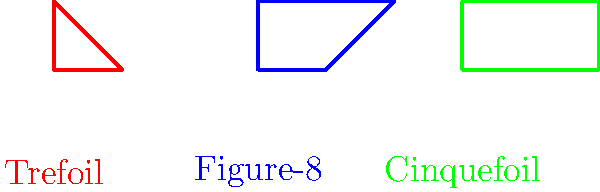Consider the three knots shown above: the Trefoil, Figure-8, and Cinquefoil knots. Which of these knots has the highest Alexander polynomial degree, and how does this relate to the knot's complexity in the grand tapestry of the universe? Let's approach this step-by-step:

1) The Alexander polynomial is a knot invariant that provides information about the complexity of a knot.

2) For the given knots:
   - Trefoil knot: Alexander polynomial is $\Delta(t) = t^2 - t + 1$
   - Figure-8 knot: Alexander polynomial is $\Delta(t) = t^2 - 3t + 1$
   - Cinquefoil knot: Alexander polynomial is $\Delta(t) = t^4 - t^3 + t^2 - t + 1$

3) The degree of the Alexander polynomial for each knot:
   - Trefoil: degree 2
   - Figure-8: degree 2
   - Cinquefoil: degree 4

4) The Cinquefoil knot has the highest Alexander polynomial degree (4).

5) In the context of pantheism, we can interpret this as follows:
   The higher degree of the Cinquefoil knot's Alexander polynomial suggests a greater complexity in its structure. This complexity can be seen as a manifestation of the intricate patterns and interconnectedness present in the universe. Just as the Cinquefoil knot requires more "information" to describe its structure, so too does the universe contain infinite complexity and depth in its fabric.

6) The Alexander polynomial degree, in this pantheistic view, becomes a metaphor for the layers of complexity and beauty inherent in the natural world. The Cinquefoil knot, with its higher degree, represents a more intricate expression of the universal design, reflecting the rich tapestry of existence that pantheism celebrates.
Answer: Cinquefoil knot; highest complexity reflecting universal intricacy 